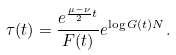<formula> <loc_0><loc_0><loc_500><loc_500>\tau ( t ) = \frac { e ^ { \frac { \mu - \nu } { 2 } t } } { F ( t ) } e ^ { \log G ( t ) N } .</formula> 